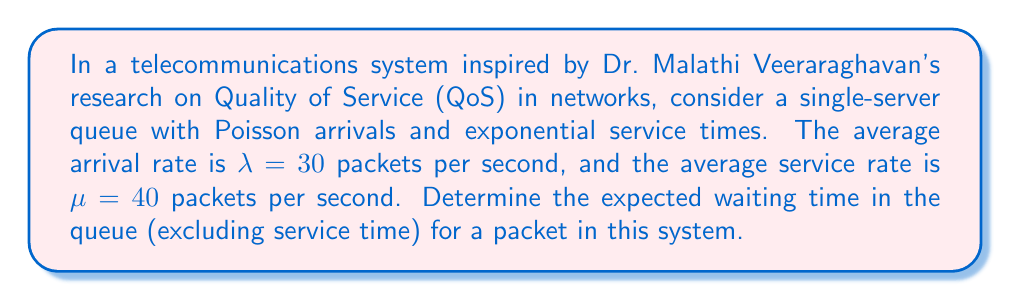Can you solve this math problem? To solve this problem, we'll use the M/M/1 queueing model, which is often applied in telecommunications systems. Here's the step-by-step solution:

1. First, we need to calculate the utilization factor $\rho$:
   $$\rho = \frac{\lambda}{\mu} = \frac{30}{40} = 0.75$$

2. The expected number of packets in the queue (excluding the one being served) is given by:
   $$L_q = \frac{\rho^2}{1-\rho} = \frac{0.75^2}{1-0.75} = \frac{0.5625}{0.25} = 2.25$$

3. Using Little's Law, we can find the expected waiting time in the queue:
   $$W_q = \frac{L_q}{\lambda}$$

4. Substituting the values:
   $$W_q = \frac{2.25}{30} = 0.075 \text{ seconds}$$

This result shows that, on average, a packet will wait 0.075 seconds in the queue before being served in this telecommunications system.
Answer: The expected waiting time in the queue for a packet is 0.075 seconds. 